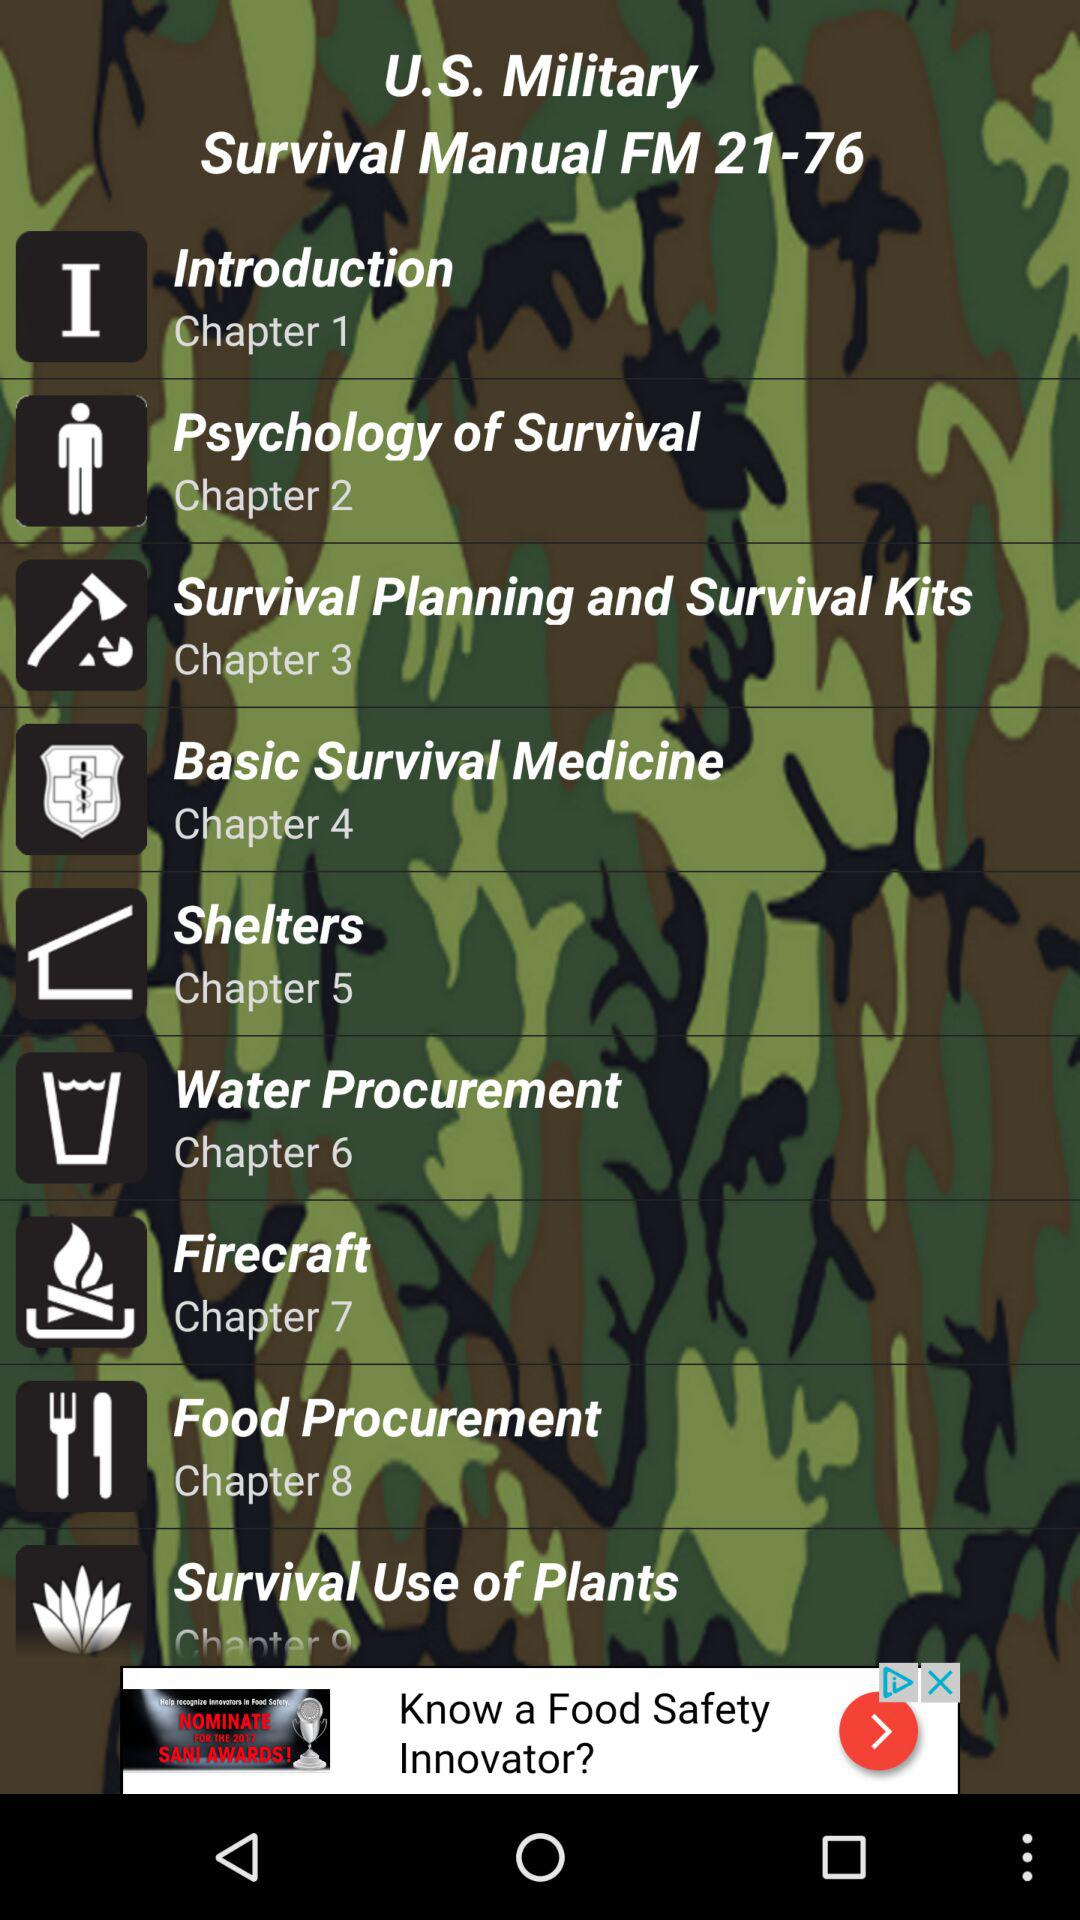How many chapters are there in the manual?
Answer the question using a single word or phrase. 9 